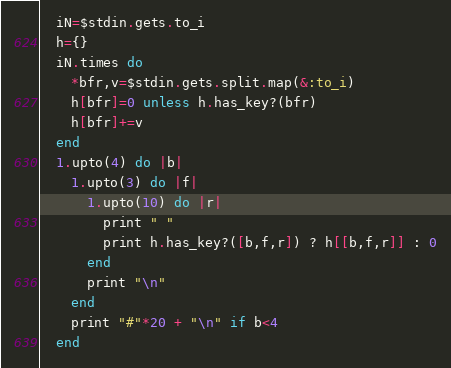Convert code to text. <code><loc_0><loc_0><loc_500><loc_500><_Ruby_>  iN=$stdin.gets.to_i
  h={}
  iN.times do
    *bfr,v=$stdin.gets.split.map(&:to_i)
    h[bfr]=0 unless h.has_key?(bfr)
    h[bfr]+=v
  end
  1.upto(4) do |b|
    1.upto(3) do |f|
      1.upto(10) do |r|
        print " "
        print h.has_key?([b,f,r]) ? h[[b,f,r]] : 0
      end
      print "\n"
    end
    print "#"*20 + "\n" if b<4
  end
</code> 